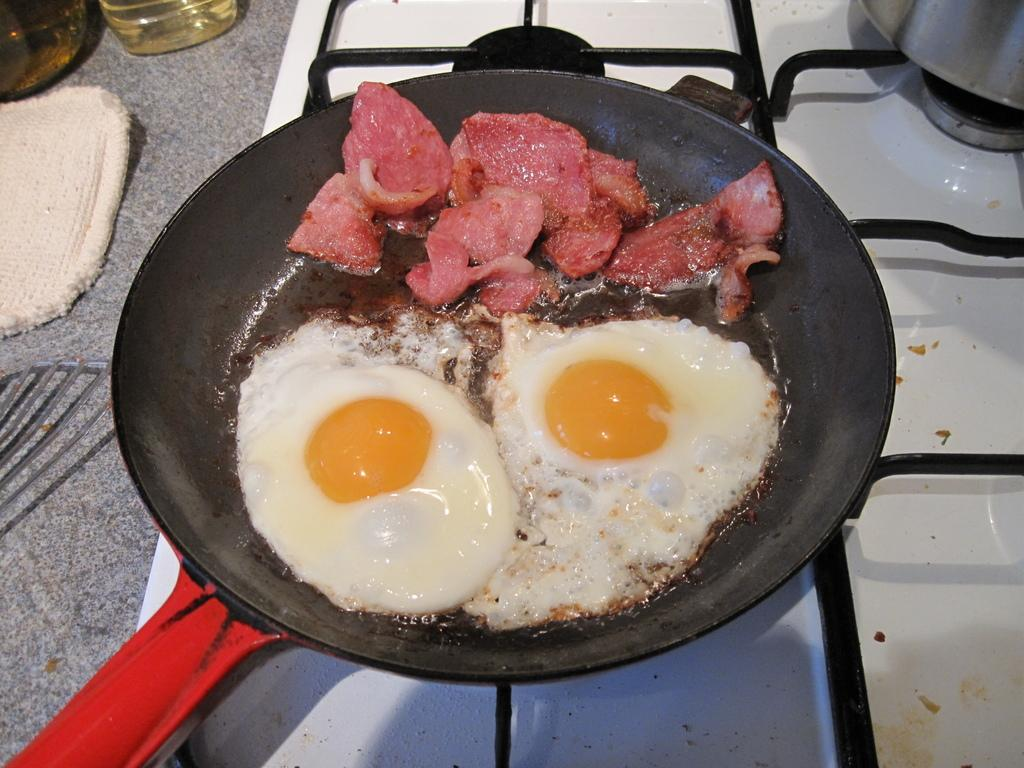What cooking appliance is visible in the image? There is a stove in the image. What is on top of the stove? There is a pan on the stove. What is inside the pan? There are two half-boiled eggs and slices of meat in the pan. What is near the stove that might be used for cooking? There is a bottle with oil near the stove. What is the purpose of the cloth near the stove? The cloth might be used for cleaning or wiping. What type of secretary can be seen working in the image? There is no secretary present in the image; it features a stove with a pan containing half-boiled eggs and slices of meat. What type of animal is visible in the image? There are no animals present in the image; it features a stove with a pan containing half-boiled eggs and slices of meat. 